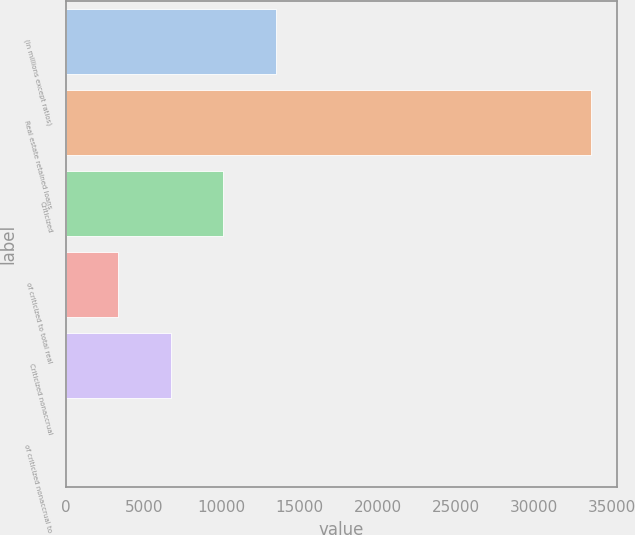Convert chart. <chart><loc_0><loc_0><loc_500><loc_500><bar_chart><fcel>(in millions except ratios)<fcel>Real estate retained loans<fcel>Criticized<fcel>of criticized to total real<fcel>Criticized nonaccrual<fcel>of criticized nonaccrual to<nl><fcel>13463.9<fcel>33659<fcel>10098<fcel>3366.28<fcel>6732.14<fcel>0.42<nl></chart> 